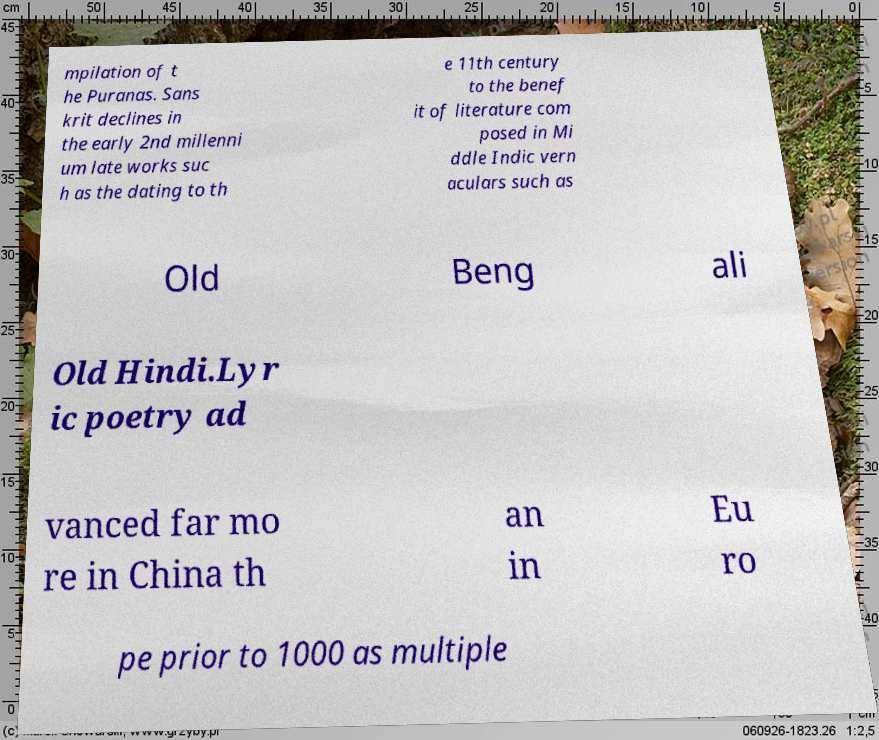For documentation purposes, I need the text within this image transcribed. Could you provide that? mpilation of t he Puranas. Sans krit declines in the early 2nd millenni um late works suc h as the dating to th e 11th century to the benef it of literature com posed in Mi ddle Indic vern aculars such as Old Beng ali Old Hindi.Lyr ic poetry ad vanced far mo re in China th an in Eu ro pe prior to 1000 as multiple 